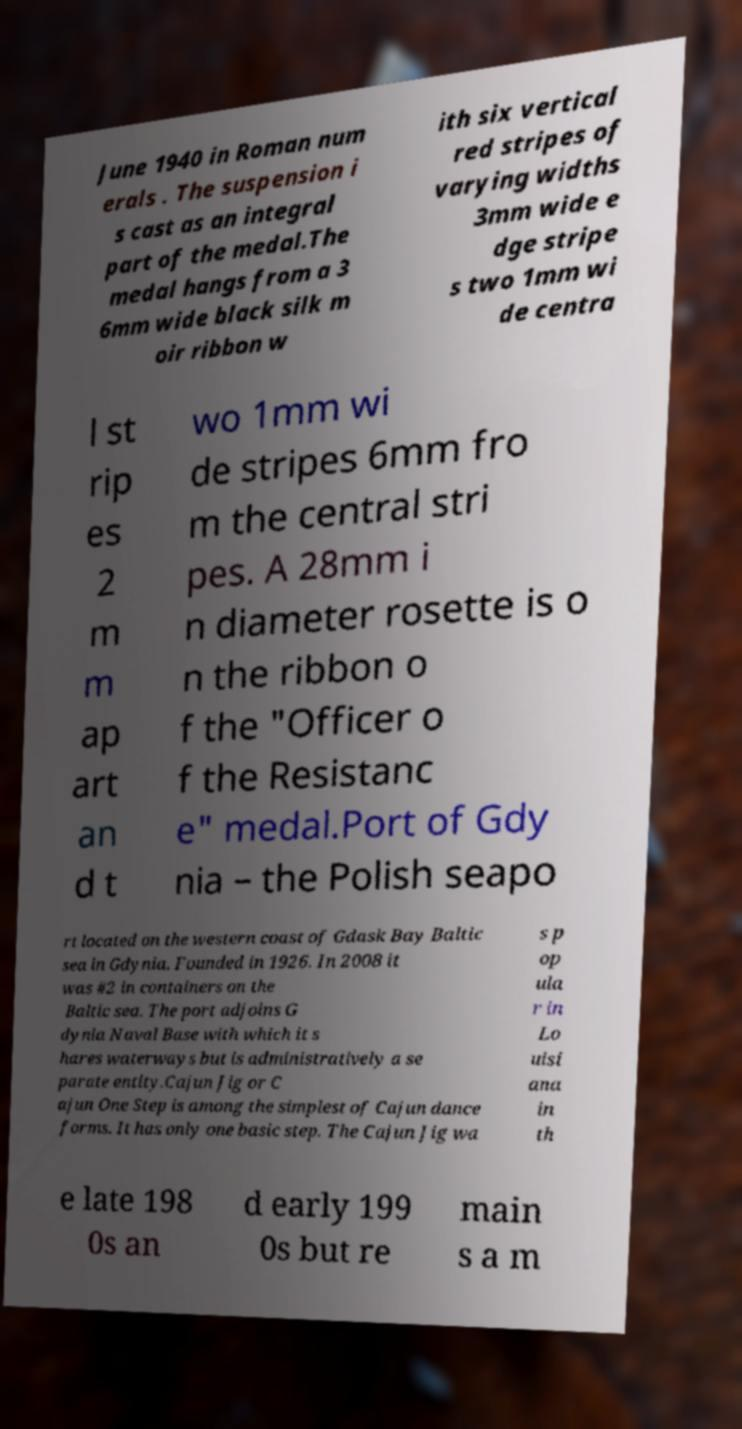Could you extract and type out the text from this image? June 1940 in Roman num erals . The suspension i s cast as an integral part of the medal.The medal hangs from a 3 6mm wide black silk m oir ribbon w ith six vertical red stripes of varying widths 3mm wide e dge stripe s two 1mm wi de centra l st rip es 2 m m ap art an d t wo 1mm wi de stripes 6mm fro m the central stri pes. A 28mm i n diameter rosette is o n the ribbon o f the "Officer o f the Resistanc e" medal.Port of Gdy nia – the Polish seapo rt located on the western coast of Gdask Bay Baltic sea in Gdynia. Founded in 1926. In 2008 it was #2 in containers on the Baltic sea. The port adjoins G dynia Naval Base with which it s hares waterways but is administratively a se parate entity.Cajun Jig or C ajun One Step is among the simplest of Cajun dance forms. It has only one basic step. The Cajun Jig wa s p op ula r in Lo uisi ana in th e late 198 0s an d early 199 0s but re main s a m 